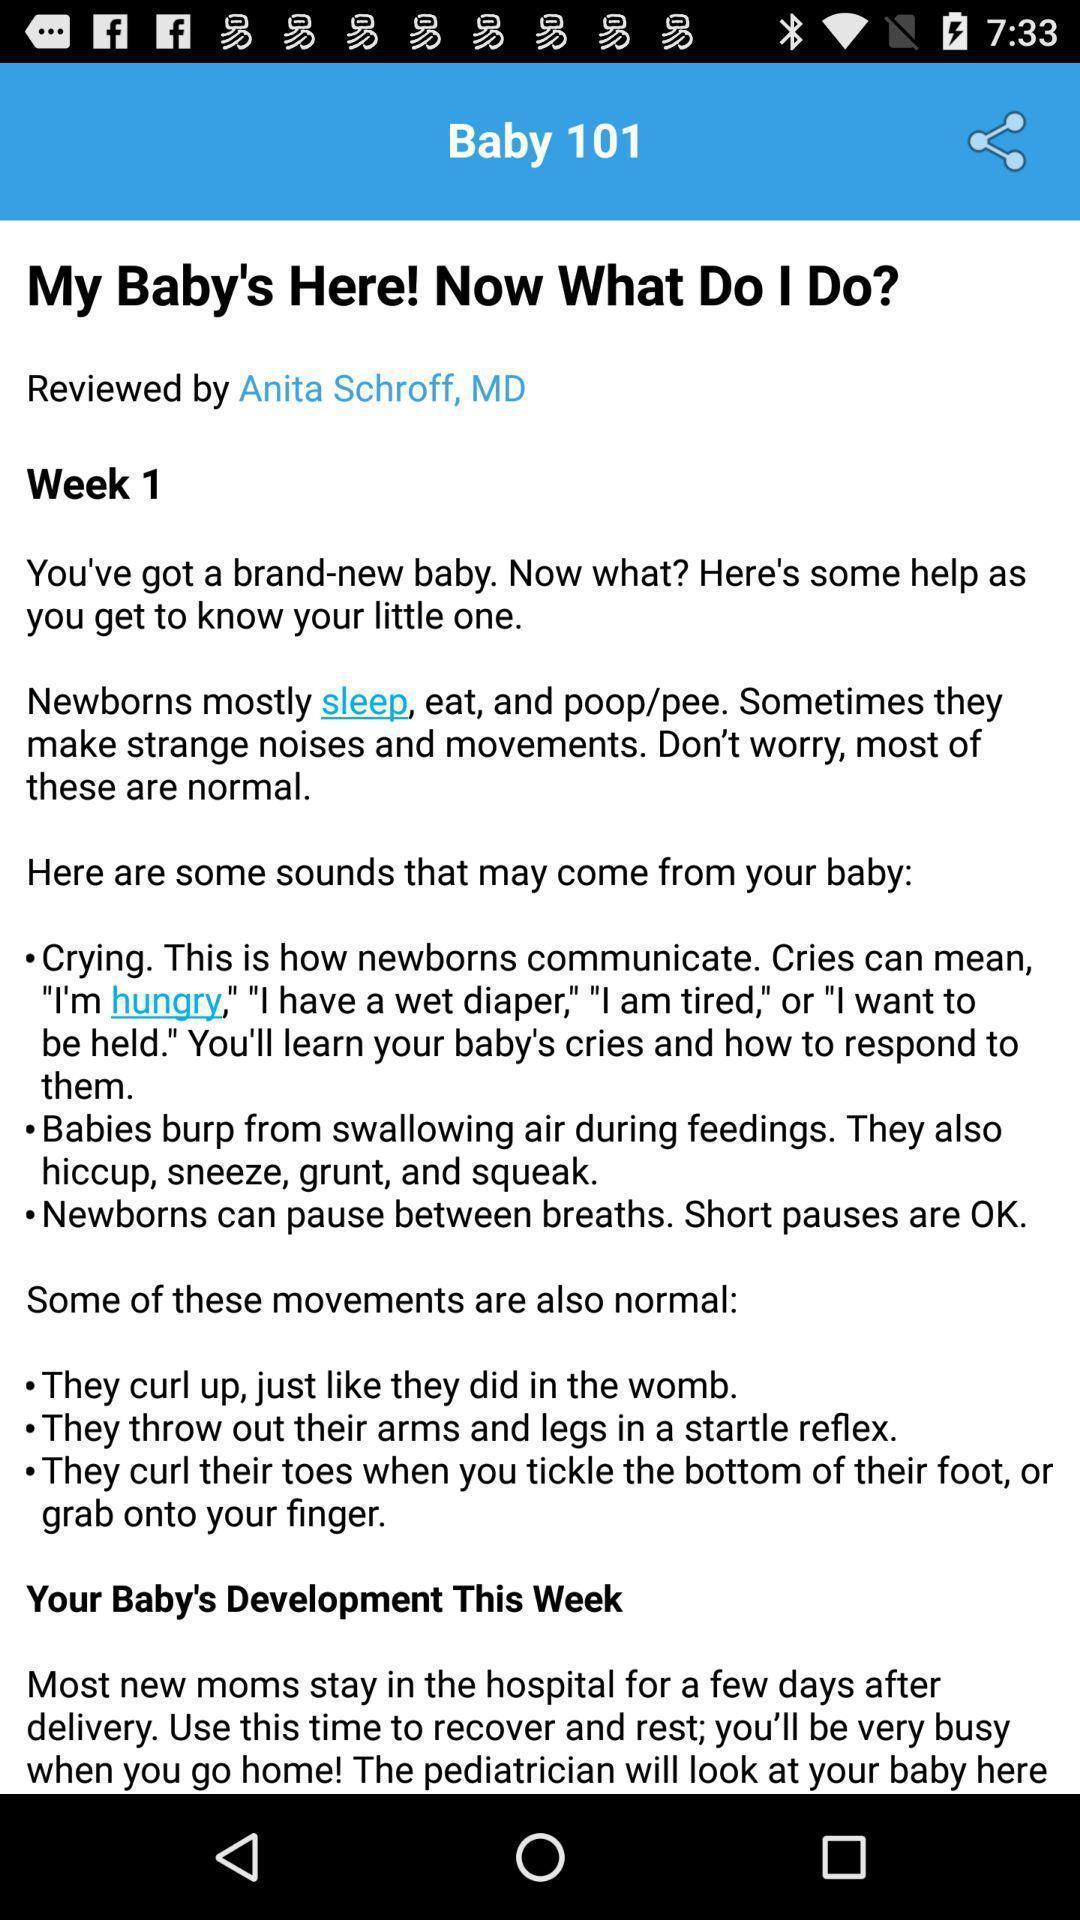What can you discern from this picture? Text information for baby care in a baby app. 